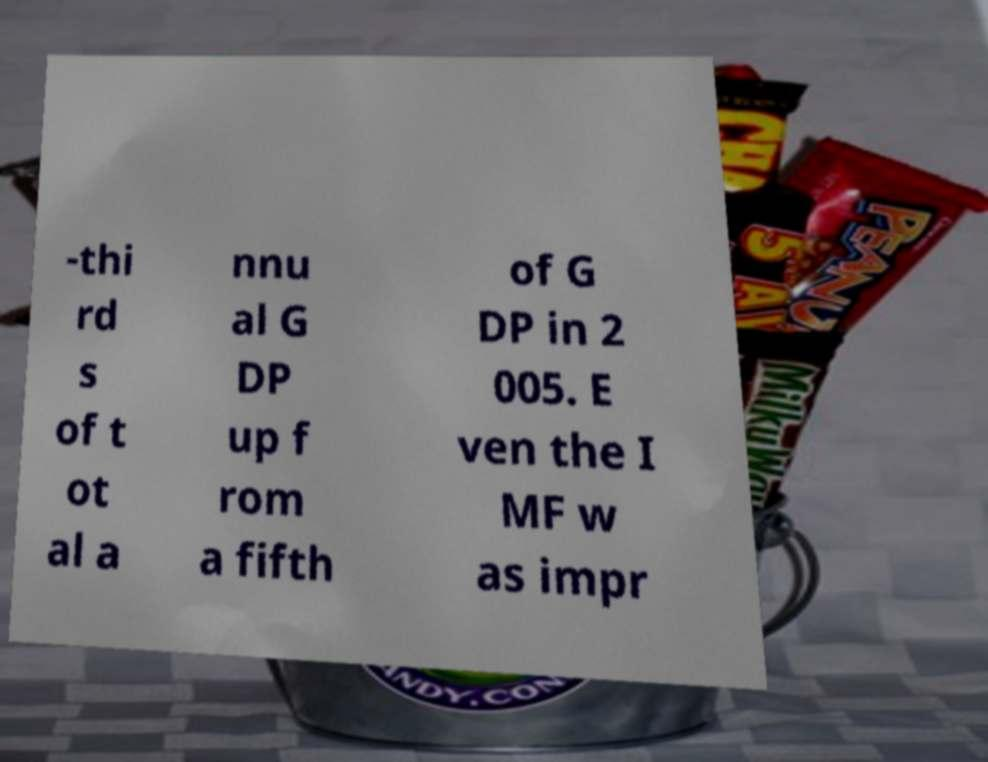There's text embedded in this image that I need extracted. Can you transcribe it verbatim? -thi rd s of t ot al a nnu al G DP up f rom a fifth of G DP in 2 005. E ven the I MF w as impr 